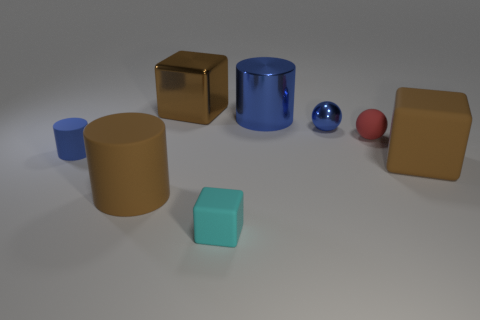Subtract all brown cubes. How many cubes are left? 1 Add 1 big objects. How many objects exist? 9 Add 4 red balls. How many red balls are left? 5 Add 2 large cylinders. How many large cylinders exist? 4 Subtract 0 red cylinders. How many objects are left? 8 Subtract all cubes. How many objects are left? 5 Subtract all big cyan rubber cylinders. Subtract all cyan cubes. How many objects are left? 7 